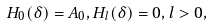Convert formula to latex. <formula><loc_0><loc_0><loc_500><loc_500>H _ { 0 } ( \delta ) = A _ { 0 } , H _ { l } ( \delta ) = 0 , l > 0 ,</formula> 